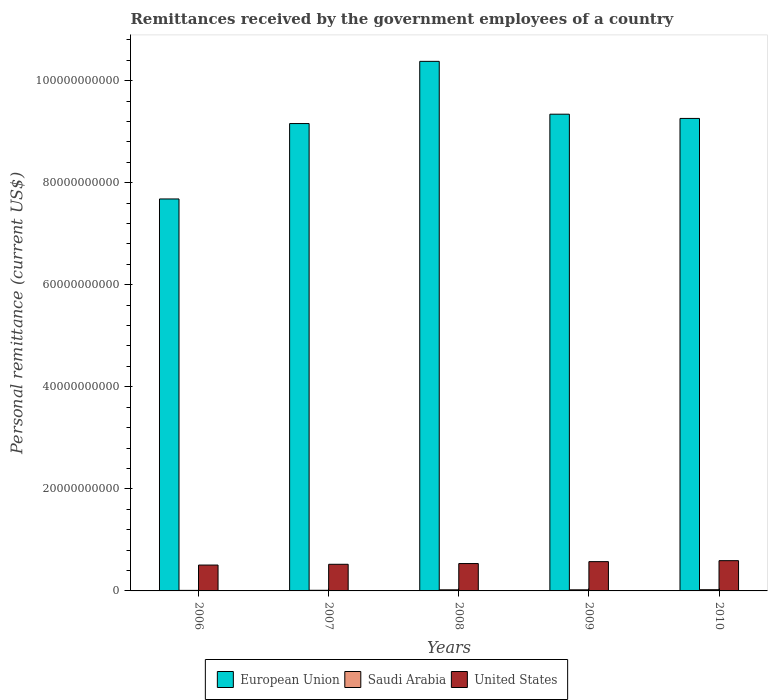How many different coloured bars are there?
Give a very brief answer. 3. How many groups of bars are there?
Provide a short and direct response. 5. Are the number of bars per tick equal to the number of legend labels?
Provide a succinct answer. Yes. Are the number of bars on each tick of the X-axis equal?
Give a very brief answer. Yes. What is the label of the 1st group of bars from the left?
Give a very brief answer. 2006. In how many cases, is the number of bars for a given year not equal to the number of legend labels?
Provide a succinct answer. 0. What is the remittances received by the government employees in European Union in 2008?
Ensure brevity in your answer.  1.04e+11. Across all years, what is the maximum remittances received by the government employees in United States?
Your answer should be compact. 5.93e+09. Across all years, what is the minimum remittances received by the government employees in European Union?
Your response must be concise. 7.68e+1. In which year was the remittances received by the government employees in Saudi Arabia maximum?
Offer a very short reply. 2010. In which year was the remittances received by the government employees in United States minimum?
Keep it short and to the point. 2006. What is the total remittances received by the government employees in Saudi Arabia in the graph?
Provide a short and direct response. 8.96e+08. What is the difference between the remittances received by the government employees in United States in 2008 and that in 2010?
Provide a succinct answer. -5.66e+08. What is the difference between the remittances received by the government employees in European Union in 2008 and the remittances received by the government employees in Saudi Arabia in 2009?
Your answer should be compact. 1.04e+11. What is the average remittances received by the government employees in United States per year?
Ensure brevity in your answer.  5.46e+09. In the year 2006, what is the difference between the remittances received by the government employees in United States and remittances received by the government employees in Saudi Arabia?
Keep it short and to the point. 4.96e+09. What is the ratio of the remittances received by the government employees in European Union in 2008 to that in 2009?
Ensure brevity in your answer.  1.11. Is the remittances received by the government employees in Saudi Arabia in 2009 less than that in 2010?
Offer a terse response. Yes. What is the difference between the highest and the second highest remittances received by the government employees in European Union?
Keep it short and to the point. 1.04e+1. What is the difference between the highest and the lowest remittances received by the government employees in European Union?
Ensure brevity in your answer.  2.70e+1. What does the 1st bar from the left in 2010 represents?
Offer a terse response. European Union. Is it the case that in every year, the sum of the remittances received by the government employees in United States and remittances received by the government employees in Saudi Arabia is greater than the remittances received by the government employees in European Union?
Give a very brief answer. No. Are all the bars in the graph horizontal?
Offer a very short reply. No. How many years are there in the graph?
Keep it short and to the point. 5. What is the difference between two consecutive major ticks on the Y-axis?
Offer a very short reply. 2.00e+1. How many legend labels are there?
Ensure brevity in your answer.  3. What is the title of the graph?
Give a very brief answer. Remittances received by the government employees of a country. What is the label or title of the X-axis?
Provide a succinct answer. Years. What is the label or title of the Y-axis?
Provide a succinct answer. Personal remittance (current US$). What is the Personal remittance (current US$) of European Union in 2006?
Offer a very short reply. 7.68e+1. What is the Personal remittance (current US$) in Saudi Arabia in 2006?
Provide a short and direct response. 1.06e+08. What is the Personal remittance (current US$) in United States in 2006?
Provide a short and direct response. 5.07e+09. What is the Personal remittance (current US$) of European Union in 2007?
Provide a succinct answer. 9.16e+1. What is the Personal remittance (current US$) in Saudi Arabia in 2007?
Your answer should be compact. 1.24e+08. What is the Personal remittance (current US$) of United States in 2007?
Provide a short and direct response. 5.22e+09. What is the Personal remittance (current US$) of European Union in 2008?
Keep it short and to the point. 1.04e+11. What is the Personal remittance (current US$) in Saudi Arabia in 2008?
Provide a succinct answer. 2.16e+08. What is the Personal remittance (current US$) of United States in 2008?
Provide a short and direct response. 5.36e+09. What is the Personal remittance (current US$) in European Union in 2009?
Offer a very short reply. 9.34e+1. What is the Personal remittance (current US$) of Saudi Arabia in 2009?
Keep it short and to the point. 2.14e+08. What is the Personal remittance (current US$) of United States in 2009?
Your answer should be compact. 5.74e+09. What is the Personal remittance (current US$) in European Union in 2010?
Your response must be concise. 9.26e+1. What is the Personal remittance (current US$) in Saudi Arabia in 2010?
Offer a terse response. 2.36e+08. What is the Personal remittance (current US$) of United States in 2010?
Your answer should be compact. 5.93e+09. Across all years, what is the maximum Personal remittance (current US$) in European Union?
Provide a short and direct response. 1.04e+11. Across all years, what is the maximum Personal remittance (current US$) of Saudi Arabia?
Make the answer very short. 2.36e+08. Across all years, what is the maximum Personal remittance (current US$) in United States?
Make the answer very short. 5.93e+09. Across all years, what is the minimum Personal remittance (current US$) of European Union?
Give a very brief answer. 7.68e+1. Across all years, what is the minimum Personal remittance (current US$) in Saudi Arabia?
Provide a short and direct response. 1.06e+08. Across all years, what is the minimum Personal remittance (current US$) in United States?
Ensure brevity in your answer.  5.07e+09. What is the total Personal remittance (current US$) in European Union in the graph?
Your answer should be compact. 4.58e+11. What is the total Personal remittance (current US$) in Saudi Arabia in the graph?
Provide a succinct answer. 8.96e+08. What is the total Personal remittance (current US$) of United States in the graph?
Give a very brief answer. 2.73e+1. What is the difference between the Personal remittance (current US$) in European Union in 2006 and that in 2007?
Keep it short and to the point. -1.48e+1. What is the difference between the Personal remittance (current US$) in Saudi Arabia in 2006 and that in 2007?
Ensure brevity in your answer.  -1.78e+07. What is the difference between the Personal remittance (current US$) in United States in 2006 and that in 2007?
Ensure brevity in your answer.  -1.51e+08. What is the difference between the Personal remittance (current US$) of European Union in 2006 and that in 2008?
Make the answer very short. -2.70e+1. What is the difference between the Personal remittance (current US$) of Saudi Arabia in 2006 and that in 2008?
Provide a short and direct response. -1.10e+08. What is the difference between the Personal remittance (current US$) of United States in 2006 and that in 2008?
Provide a short and direct response. -2.96e+08. What is the difference between the Personal remittance (current US$) in European Union in 2006 and that in 2009?
Offer a very short reply. -1.66e+1. What is the difference between the Personal remittance (current US$) in Saudi Arabia in 2006 and that in 2009?
Ensure brevity in your answer.  -1.09e+08. What is the difference between the Personal remittance (current US$) in United States in 2006 and that in 2009?
Ensure brevity in your answer.  -6.72e+08. What is the difference between the Personal remittance (current US$) in European Union in 2006 and that in 2010?
Provide a short and direct response. -1.58e+1. What is the difference between the Personal remittance (current US$) in Saudi Arabia in 2006 and that in 2010?
Your answer should be compact. -1.31e+08. What is the difference between the Personal remittance (current US$) in United States in 2006 and that in 2010?
Keep it short and to the point. -8.62e+08. What is the difference between the Personal remittance (current US$) of European Union in 2007 and that in 2008?
Offer a very short reply. -1.22e+1. What is the difference between the Personal remittance (current US$) in Saudi Arabia in 2007 and that in 2008?
Ensure brevity in your answer.  -9.26e+07. What is the difference between the Personal remittance (current US$) in United States in 2007 and that in 2008?
Keep it short and to the point. -1.45e+08. What is the difference between the Personal remittance (current US$) in European Union in 2007 and that in 2009?
Ensure brevity in your answer.  -1.84e+09. What is the difference between the Personal remittance (current US$) of Saudi Arabia in 2007 and that in 2009?
Your answer should be very brief. -9.09e+07. What is the difference between the Personal remittance (current US$) of United States in 2007 and that in 2009?
Provide a succinct answer. -5.21e+08. What is the difference between the Personal remittance (current US$) in European Union in 2007 and that in 2010?
Keep it short and to the point. -1.01e+09. What is the difference between the Personal remittance (current US$) in Saudi Arabia in 2007 and that in 2010?
Give a very brief answer. -1.13e+08. What is the difference between the Personal remittance (current US$) in United States in 2007 and that in 2010?
Your response must be concise. -7.11e+08. What is the difference between the Personal remittance (current US$) in European Union in 2008 and that in 2009?
Keep it short and to the point. 1.04e+1. What is the difference between the Personal remittance (current US$) of Saudi Arabia in 2008 and that in 2009?
Your response must be concise. 1.79e+06. What is the difference between the Personal remittance (current US$) in United States in 2008 and that in 2009?
Make the answer very short. -3.76e+08. What is the difference between the Personal remittance (current US$) in European Union in 2008 and that in 2010?
Your answer should be very brief. 1.12e+1. What is the difference between the Personal remittance (current US$) in Saudi Arabia in 2008 and that in 2010?
Keep it short and to the point. -2.03e+07. What is the difference between the Personal remittance (current US$) of United States in 2008 and that in 2010?
Your response must be concise. -5.66e+08. What is the difference between the Personal remittance (current US$) in European Union in 2009 and that in 2010?
Your response must be concise. 8.29e+08. What is the difference between the Personal remittance (current US$) of Saudi Arabia in 2009 and that in 2010?
Provide a succinct answer. -2.21e+07. What is the difference between the Personal remittance (current US$) in United States in 2009 and that in 2010?
Your answer should be very brief. -1.90e+08. What is the difference between the Personal remittance (current US$) in European Union in 2006 and the Personal remittance (current US$) in Saudi Arabia in 2007?
Provide a short and direct response. 7.67e+1. What is the difference between the Personal remittance (current US$) in European Union in 2006 and the Personal remittance (current US$) in United States in 2007?
Keep it short and to the point. 7.16e+1. What is the difference between the Personal remittance (current US$) of Saudi Arabia in 2006 and the Personal remittance (current US$) of United States in 2007?
Your response must be concise. -5.11e+09. What is the difference between the Personal remittance (current US$) of European Union in 2006 and the Personal remittance (current US$) of Saudi Arabia in 2008?
Offer a very short reply. 7.66e+1. What is the difference between the Personal remittance (current US$) in European Union in 2006 and the Personal remittance (current US$) in United States in 2008?
Your answer should be very brief. 7.14e+1. What is the difference between the Personal remittance (current US$) of Saudi Arabia in 2006 and the Personal remittance (current US$) of United States in 2008?
Make the answer very short. -5.26e+09. What is the difference between the Personal remittance (current US$) in European Union in 2006 and the Personal remittance (current US$) in Saudi Arabia in 2009?
Your answer should be compact. 7.66e+1. What is the difference between the Personal remittance (current US$) in European Union in 2006 and the Personal remittance (current US$) in United States in 2009?
Your answer should be very brief. 7.11e+1. What is the difference between the Personal remittance (current US$) of Saudi Arabia in 2006 and the Personal remittance (current US$) of United States in 2009?
Make the answer very short. -5.63e+09. What is the difference between the Personal remittance (current US$) in European Union in 2006 and the Personal remittance (current US$) in Saudi Arabia in 2010?
Ensure brevity in your answer.  7.66e+1. What is the difference between the Personal remittance (current US$) in European Union in 2006 and the Personal remittance (current US$) in United States in 2010?
Your answer should be compact. 7.09e+1. What is the difference between the Personal remittance (current US$) in Saudi Arabia in 2006 and the Personal remittance (current US$) in United States in 2010?
Provide a short and direct response. -5.82e+09. What is the difference between the Personal remittance (current US$) of European Union in 2007 and the Personal remittance (current US$) of Saudi Arabia in 2008?
Your answer should be very brief. 9.14e+1. What is the difference between the Personal remittance (current US$) of European Union in 2007 and the Personal remittance (current US$) of United States in 2008?
Provide a succinct answer. 8.62e+1. What is the difference between the Personal remittance (current US$) in Saudi Arabia in 2007 and the Personal remittance (current US$) in United States in 2008?
Keep it short and to the point. -5.24e+09. What is the difference between the Personal remittance (current US$) of European Union in 2007 and the Personal remittance (current US$) of Saudi Arabia in 2009?
Offer a terse response. 9.14e+1. What is the difference between the Personal remittance (current US$) in European Union in 2007 and the Personal remittance (current US$) in United States in 2009?
Make the answer very short. 8.58e+1. What is the difference between the Personal remittance (current US$) in Saudi Arabia in 2007 and the Personal remittance (current US$) in United States in 2009?
Offer a terse response. -5.62e+09. What is the difference between the Personal remittance (current US$) in European Union in 2007 and the Personal remittance (current US$) in Saudi Arabia in 2010?
Provide a short and direct response. 9.13e+1. What is the difference between the Personal remittance (current US$) of European Union in 2007 and the Personal remittance (current US$) of United States in 2010?
Offer a terse response. 8.56e+1. What is the difference between the Personal remittance (current US$) of Saudi Arabia in 2007 and the Personal remittance (current US$) of United States in 2010?
Make the answer very short. -5.81e+09. What is the difference between the Personal remittance (current US$) in European Union in 2008 and the Personal remittance (current US$) in Saudi Arabia in 2009?
Offer a very short reply. 1.04e+11. What is the difference between the Personal remittance (current US$) in European Union in 2008 and the Personal remittance (current US$) in United States in 2009?
Provide a succinct answer. 9.80e+1. What is the difference between the Personal remittance (current US$) in Saudi Arabia in 2008 and the Personal remittance (current US$) in United States in 2009?
Provide a short and direct response. -5.52e+09. What is the difference between the Personal remittance (current US$) of European Union in 2008 and the Personal remittance (current US$) of Saudi Arabia in 2010?
Your answer should be very brief. 1.04e+11. What is the difference between the Personal remittance (current US$) of European Union in 2008 and the Personal remittance (current US$) of United States in 2010?
Provide a succinct answer. 9.78e+1. What is the difference between the Personal remittance (current US$) in Saudi Arabia in 2008 and the Personal remittance (current US$) in United States in 2010?
Your answer should be very brief. -5.71e+09. What is the difference between the Personal remittance (current US$) in European Union in 2009 and the Personal remittance (current US$) in Saudi Arabia in 2010?
Offer a terse response. 9.32e+1. What is the difference between the Personal remittance (current US$) of European Union in 2009 and the Personal remittance (current US$) of United States in 2010?
Offer a very short reply. 8.75e+1. What is the difference between the Personal remittance (current US$) of Saudi Arabia in 2009 and the Personal remittance (current US$) of United States in 2010?
Give a very brief answer. -5.72e+09. What is the average Personal remittance (current US$) of European Union per year?
Ensure brevity in your answer.  9.16e+1. What is the average Personal remittance (current US$) in Saudi Arabia per year?
Your answer should be compact. 1.79e+08. What is the average Personal remittance (current US$) in United States per year?
Provide a short and direct response. 5.46e+09. In the year 2006, what is the difference between the Personal remittance (current US$) of European Union and Personal remittance (current US$) of Saudi Arabia?
Ensure brevity in your answer.  7.67e+1. In the year 2006, what is the difference between the Personal remittance (current US$) in European Union and Personal remittance (current US$) in United States?
Your response must be concise. 7.17e+1. In the year 2006, what is the difference between the Personal remittance (current US$) of Saudi Arabia and Personal remittance (current US$) of United States?
Offer a very short reply. -4.96e+09. In the year 2007, what is the difference between the Personal remittance (current US$) in European Union and Personal remittance (current US$) in Saudi Arabia?
Make the answer very short. 9.15e+1. In the year 2007, what is the difference between the Personal remittance (current US$) in European Union and Personal remittance (current US$) in United States?
Make the answer very short. 8.64e+1. In the year 2007, what is the difference between the Personal remittance (current US$) in Saudi Arabia and Personal remittance (current US$) in United States?
Provide a short and direct response. -5.10e+09. In the year 2008, what is the difference between the Personal remittance (current US$) in European Union and Personal remittance (current US$) in Saudi Arabia?
Keep it short and to the point. 1.04e+11. In the year 2008, what is the difference between the Personal remittance (current US$) of European Union and Personal remittance (current US$) of United States?
Keep it short and to the point. 9.84e+1. In the year 2008, what is the difference between the Personal remittance (current US$) of Saudi Arabia and Personal remittance (current US$) of United States?
Offer a terse response. -5.15e+09. In the year 2009, what is the difference between the Personal remittance (current US$) of European Union and Personal remittance (current US$) of Saudi Arabia?
Your answer should be compact. 9.32e+1. In the year 2009, what is the difference between the Personal remittance (current US$) in European Union and Personal remittance (current US$) in United States?
Your answer should be very brief. 8.77e+1. In the year 2009, what is the difference between the Personal remittance (current US$) of Saudi Arabia and Personal remittance (current US$) of United States?
Make the answer very short. -5.53e+09. In the year 2010, what is the difference between the Personal remittance (current US$) in European Union and Personal remittance (current US$) in Saudi Arabia?
Your answer should be compact. 9.23e+1. In the year 2010, what is the difference between the Personal remittance (current US$) in European Union and Personal remittance (current US$) in United States?
Keep it short and to the point. 8.67e+1. In the year 2010, what is the difference between the Personal remittance (current US$) in Saudi Arabia and Personal remittance (current US$) in United States?
Offer a terse response. -5.69e+09. What is the ratio of the Personal remittance (current US$) in European Union in 2006 to that in 2007?
Offer a terse response. 0.84. What is the ratio of the Personal remittance (current US$) in Saudi Arabia in 2006 to that in 2007?
Give a very brief answer. 0.86. What is the ratio of the Personal remittance (current US$) in United States in 2006 to that in 2007?
Your answer should be very brief. 0.97. What is the ratio of the Personal remittance (current US$) in European Union in 2006 to that in 2008?
Provide a succinct answer. 0.74. What is the ratio of the Personal remittance (current US$) of Saudi Arabia in 2006 to that in 2008?
Keep it short and to the point. 0.49. What is the ratio of the Personal remittance (current US$) of United States in 2006 to that in 2008?
Your answer should be very brief. 0.94. What is the ratio of the Personal remittance (current US$) in European Union in 2006 to that in 2009?
Provide a short and direct response. 0.82. What is the ratio of the Personal remittance (current US$) of Saudi Arabia in 2006 to that in 2009?
Ensure brevity in your answer.  0.49. What is the ratio of the Personal remittance (current US$) of United States in 2006 to that in 2009?
Offer a very short reply. 0.88. What is the ratio of the Personal remittance (current US$) of European Union in 2006 to that in 2010?
Your answer should be very brief. 0.83. What is the ratio of the Personal remittance (current US$) in Saudi Arabia in 2006 to that in 2010?
Your answer should be very brief. 0.45. What is the ratio of the Personal remittance (current US$) in United States in 2006 to that in 2010?
Offer a very short reply. 0.85. What is the ratio of the Personal remittance (current US$) in European Union in 2007 to that in 2008?
Your response must be concise. 0.88. What is the ratio of the Personal remittance (current US$) of Saudi Arabia in 2007 to that in 2008?
Keep it short and to the point. 0.57. What is the ratio of the Personal remittance (current US$) of United States in 2007 to that in 2008?
Keep it short and to the point. 0.97. What is the ratio of the Personal remittance (current US$) of European Union in 2007 to that in 2009?
Your answer should be very brief. 0.98. What is the ratio of the Personal remittance (current US$) in Saudi Arabia in 2007 to that in 2009?
Your answer should be very brief. 0.58. What is the ratio of the Personal remittance (current US$) in United States in 2007 to that in 2009?
Your response must be concise. 0.91. What is the ratio of the Personal remittance (current US$) of Saudi Arabia in 2007 to that in 2010?
Your answer should be compact. 0.52. What is the ratio of the Personal remittance (current US$) of United States in 2007 to that in 2010?
Your response must be concise. 0.88. What is the ratio of the Personal remittance (current US$) in European Union in 2008 to that in 2009?
Provide a short and direct response. 1.11. What is the ratio of the Personal remittance (current US$) in Saudi Arabia in 2008 to that in 2009?
Offer a terse response. 1.01. What is the ratio of the Personal remittance (current US$) in United States in 2008 to that in 2009?
Offer a very short reply. 0.93. What is the ratio of the Personal remittance (current US$) of European Union in 2008 to that in 2010?
Offer a terse response. 1.12. What is the ratio of the Personal remittance (current US$) of Saudi Arabia in 2008 to that in 2010?
Keep it short and to the point. 0.91. What is the ratio of the Personal remittance (current US$) of United States in 2008 to that in 2010?
Your answer should be very brief. 0.9. What is the ratio of the Personal remittance (current US$) of Saudi Arabia in 2009 to that in 2010?
Make the answer very short. 0.91. What is the difference between the highest and the second highest Personal remittance (current US$) of European Union?
Your answer should be very brief. 1.04e+1. What is the difference between the highest and the second highest Personal remittance (current US$) of Saudi Arabia?
Ensure brevity in your answer.  2.03e+07. What is the difference between the highest and the second highest Personal remittance (current US$) of United States?
Ensure brevity in your answer.  1.90e+08. What is the difference between the highest and the lowest Personal remittance (current US$) of European Union?
Offer a very short reply. 2.70e+1. What is the difference between the highest and the lowest Personal remittance (current US$) in Saudi Arabia?
Your answer should be compact. 1.31e+08. What is the difference between the highest and the lowest Personal remittance (current US$) in United States?
Make the answer very short. 8.62e+08. 